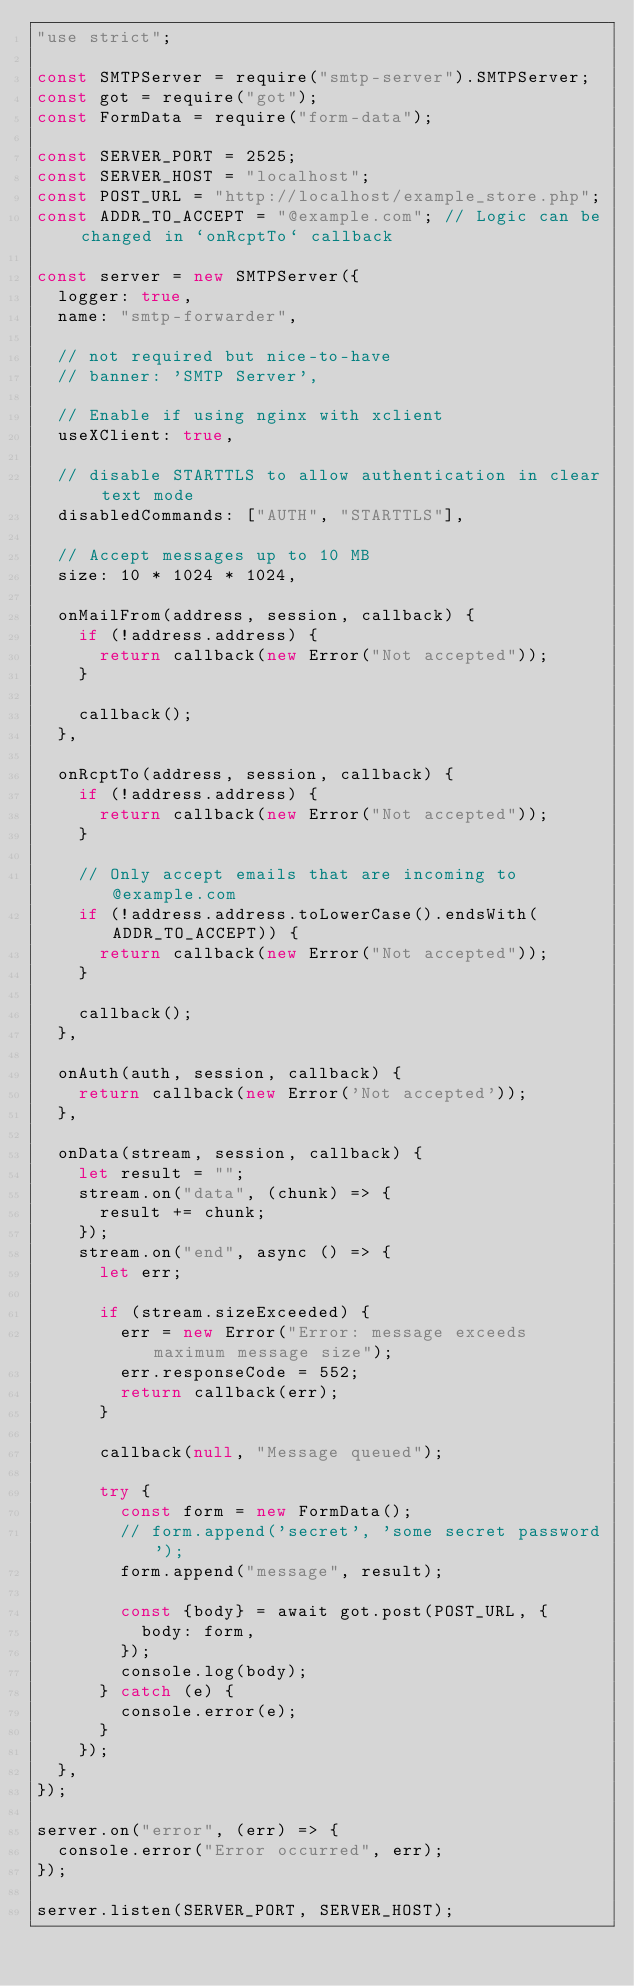<code> <loc_0><loc_0><loc_500><loc_500><_JavaScript_>"use strict";

const SMTPServer = require("smtp-server").SMTPServer;
const got = require("got");
const FormData = require("form-data");

const SERVER_PORT = 2525;
const SERVER_HOST = "localhost";
const POST_URL = "http://localhost/example_store.php";
const ADDR_TO_ACCEPT = "@example.com"; // Logic can be changed in `onRcptTo` callback

const server = new SMTPServer({
	logger: true,
	name: "smtp-forwarder",

	// not required but nice-to-have
	// banner: 'SMTP Server',

	// Enable if using nginx with xclient
	useXClient: true,

	// disable STARTTLS to allow authentication in clear text mode
	disabledCommands: ["AUTH", "STARTTLS"],

	// Accept messages up to 10 MB
	size: 10 * 1024 * 1024,

	onMailFrom(address, session, callback) {
		if (!address.address) {
			return callback(new Error("Not accepted"));
		}

		callback();
	},

	onRcptTo(address, session, callback) {
		if (!address.address) {
			return callback(new Error("Not accepted"));
		}

		// Only accept emails that are incoming to @example.com
		if (!address.address.toLowerCase().endsWith(ADDR_TO_ACCEPT)) {
			return callback(new Error("Not accepted"));
		}

		callback();
	},

	onAuth(auth, session, callback) {
		return callback(new Error('Not accepted'));
	},

	onData(stream, session, callback) {
		let result = "";
		stream.on("data", (chunk) => {
			result += chunk;
		});
		stream.on("end", async () => {
			let err;

			if (stream.sizeExceeded) {
				err = new Error("Error: message exceeds maximum message size");
				err.responseCode = 552;
				return callback(err);
			}

			callback(null, "Message queued");

			try {
				const form = new FormData();
				// form.append('secret', 'some secret password');
				form.append("message", result);

				const {body} = await got.post(POST_URL, {
					body: form,
				});
				console.log(body);
			} catch (e) {
				console.error(e);
			}
		});
	},
});

server.on("error", (err) => {
	console.error("Error occurred", err);
});

server.listen(SERVER_PORT, SERVER_HOST);
</code> 